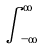Convert formula to latex. <formula><loc_0><loc_0><loc_500><loc_500>\int _ { - \infty } ^ { \infty }</formula> 